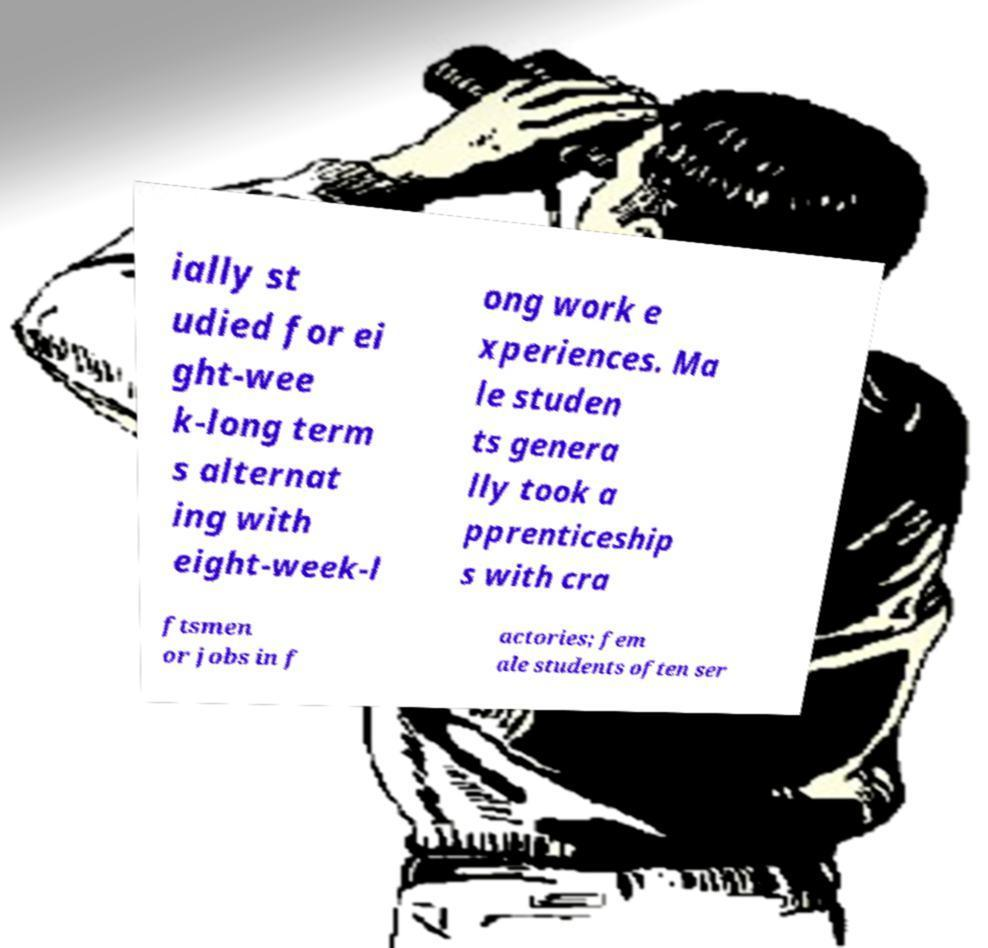For documentation purposes, I need the text within this image transcribed. Could you provide that? ially st udied for ei ght-wee k-long term s alternat ing with eight-week-l ong work e xperiences. Ma le studen ts genera lly took a pprenticeship s with cra ftsmen or jobs in f actories; fem ale students often ser 